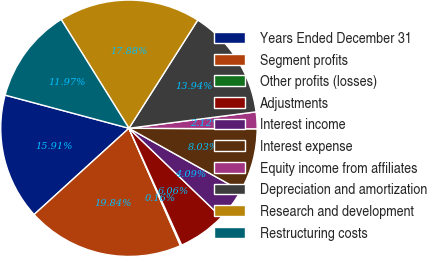<chart> <loc_0><loc_0><loc_500><loc_500><pie_chart><fcel>Years Ended December 31<fcel>Segment profits<fcel>Other profits (losses)<fcel>Adjustments<fcel>Interest income<fcel>Interest expense<fcel>Equity income from affiliates<fcel>Depreciation and amortization<fcel>Research and development<fcel>Restructuring costs<nl><fcel>15.91%<fcel>19.84%<fcel>0.16%<fcel>6.06%<fcel>4.09%<fcel>8.03%<fcel>2.12%<fcel>13.94%<fcel>17.88%<fcel>11.97%<nl></chart> 